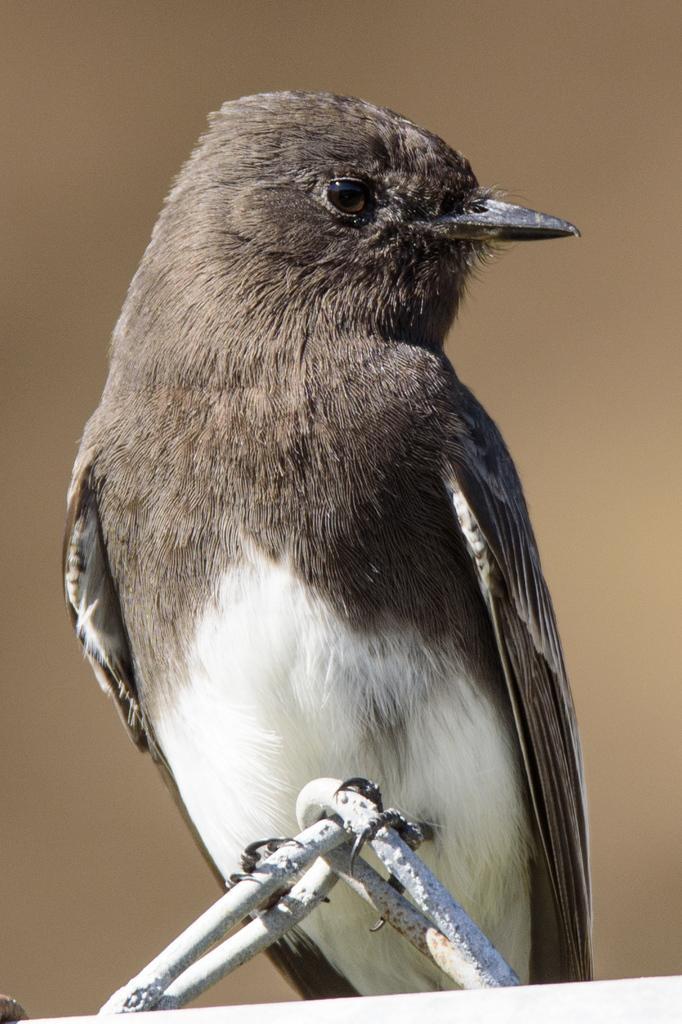In one or two sentences, can you explain what this image depicts? In the center of the image there is a bird. 